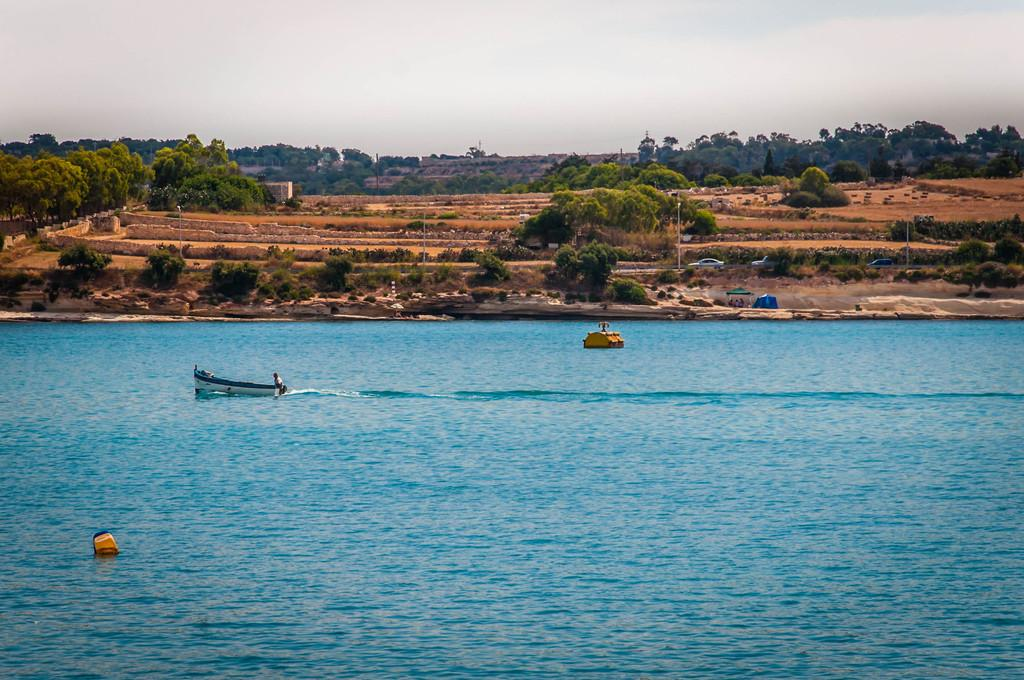What is on the water in the image? There are boats on the water in the image. What can be seen in the background of the image? There are trees, poles, vehicles, and the sky visible in the background. What type of camp can be seen near the edge of the water in the image? There is no camp present in the image; it features boats on the water and various elements in the background. 